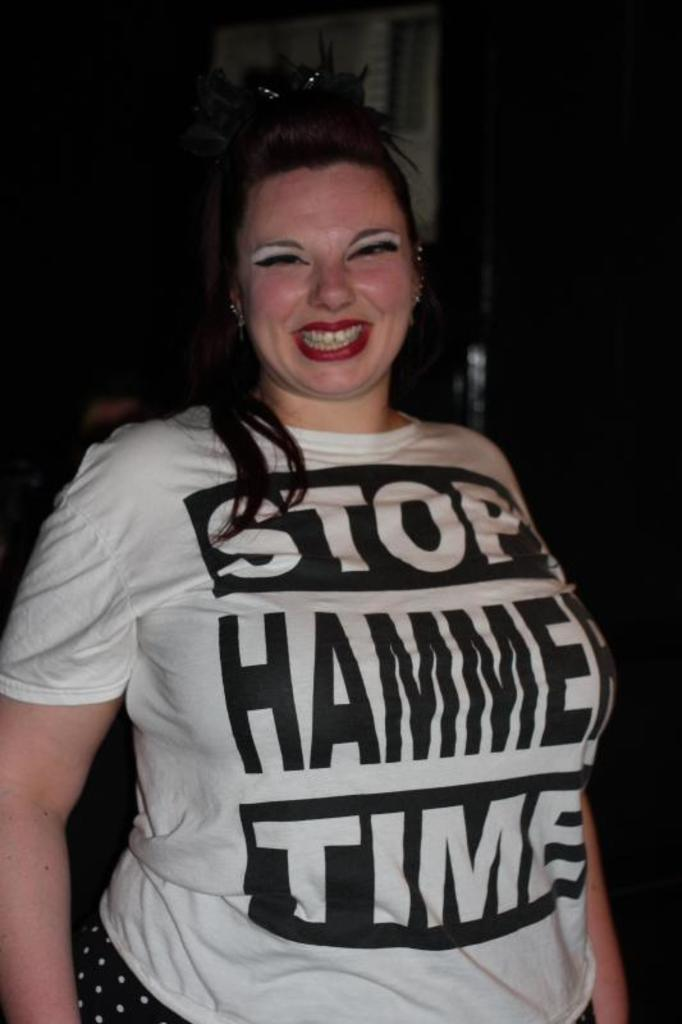<image>
Describe the image concisely. a lady that has the word stop on her shirt 